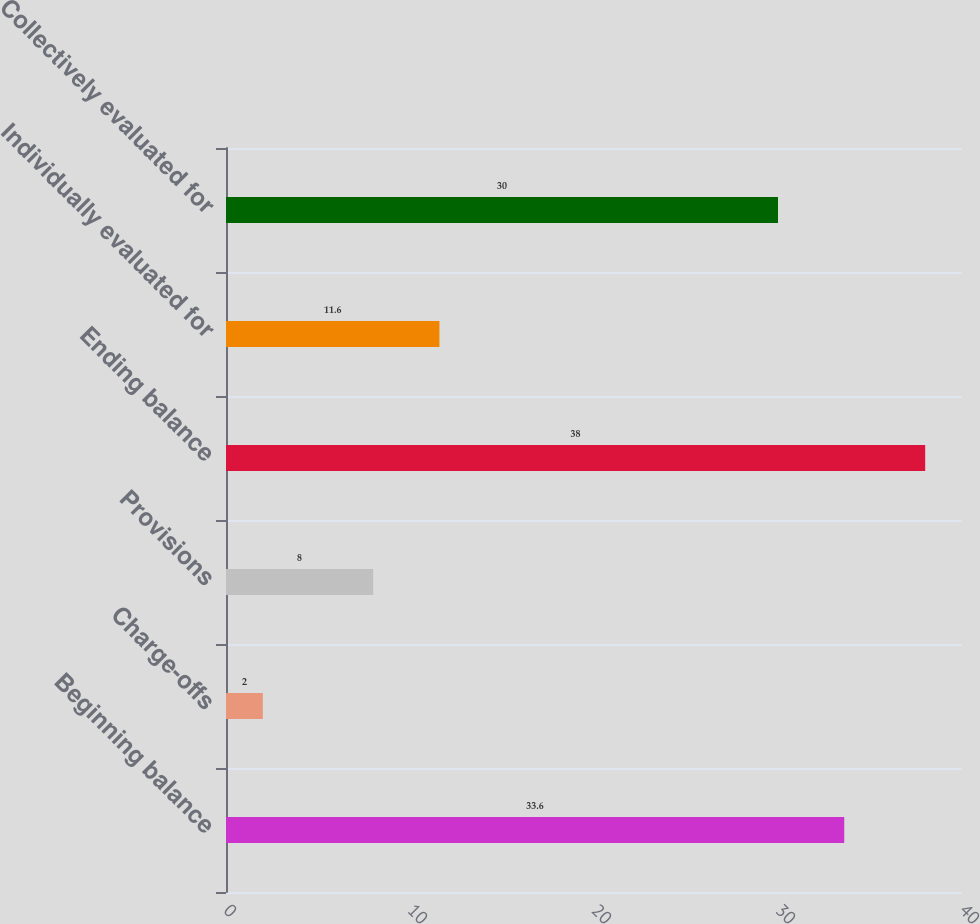Convert chart. <chart><loc_0><loc_0><loc_500><loc_500><bar_chart><fcel>Beginning balance<fcel>Charge-offs<fcel>Provisions<fcel>Ending balance<fcel>Individually evaluated for<fcel>Collectively evaluated for<nl><fcel>33.6<fcel>2<fcel>8<fcel>38<fcel>11.6<fcel>30<nl></chart> 